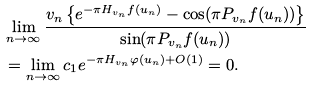<formula> <loc_0><loc_0><loc_500><loc_500>& \lim _ { n \rightarrow \infty } \frac { v _ { n } \left \{ e ^ { - \pi H _ { v _ { n } } f ( u _ { n } ) } - \cos ( \pi P _ { v _ { n } } f ( u _ { n } ) ) \right \} } { \sin ( \pi P _ { v _ { n } } f ( u _ { n } ) ) } \\ & = \lim _ { n \rightarrow \infty } c _ { 1 } e ^ { - \pi H _ { v _ { n } } \varphi ( u _ { n } ) + O ( 1 ) } = 0 .</formula> 